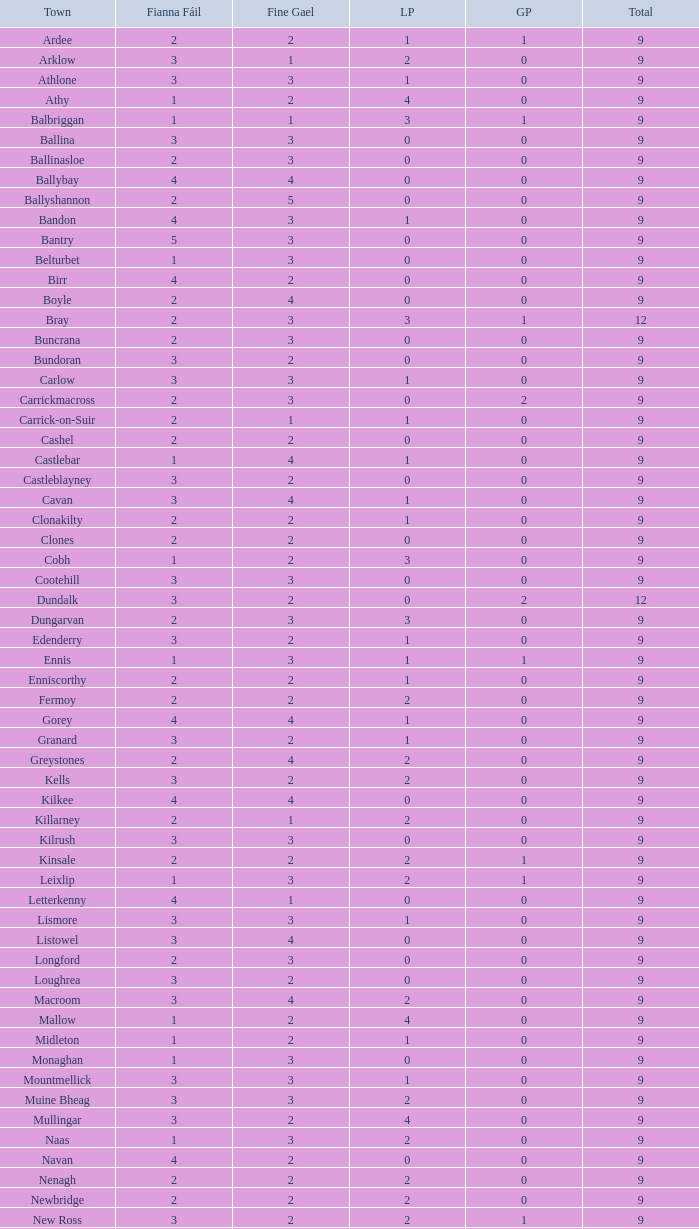How many are in the Labour Party of a Fianna Fail of 3 with a total higher than 9 and more than 2 in the Green Party? None. 